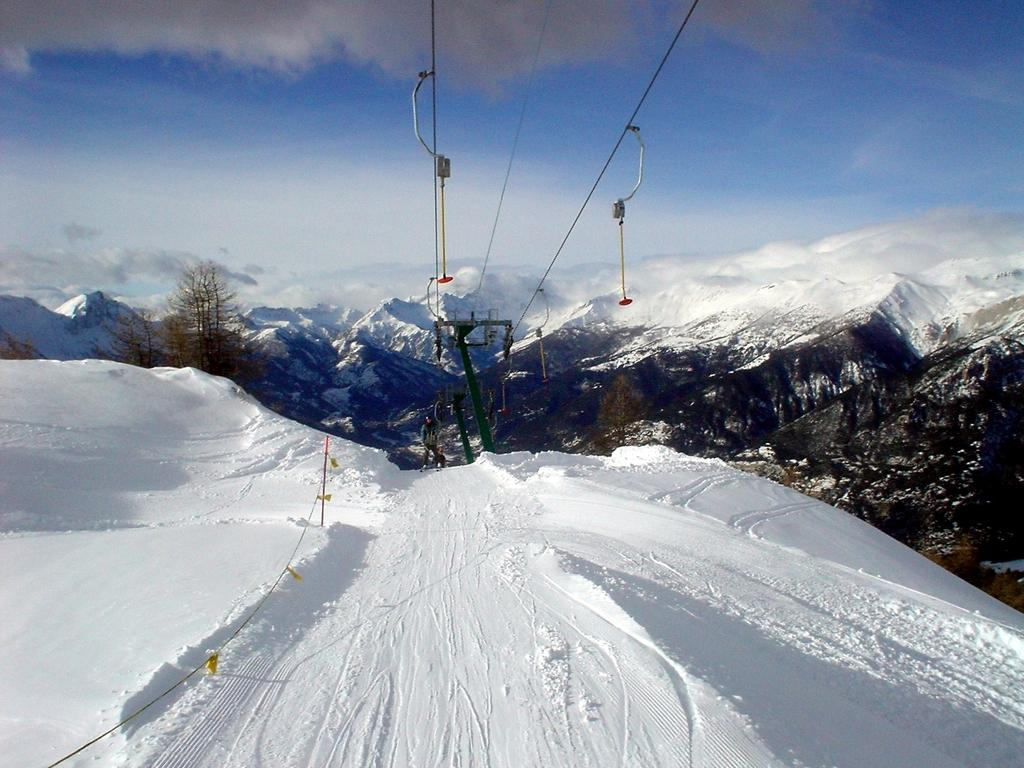What is the person in the image standing on? The person is standing on the snow. What type of terrain can be seen in the image? There are hills with snow in the image. What natural elements are present in the image? There are trees in the image. What sense is the person using to interact with the picture? The person in the image is not interacting with a picture; they are standing on snow in the real world. 